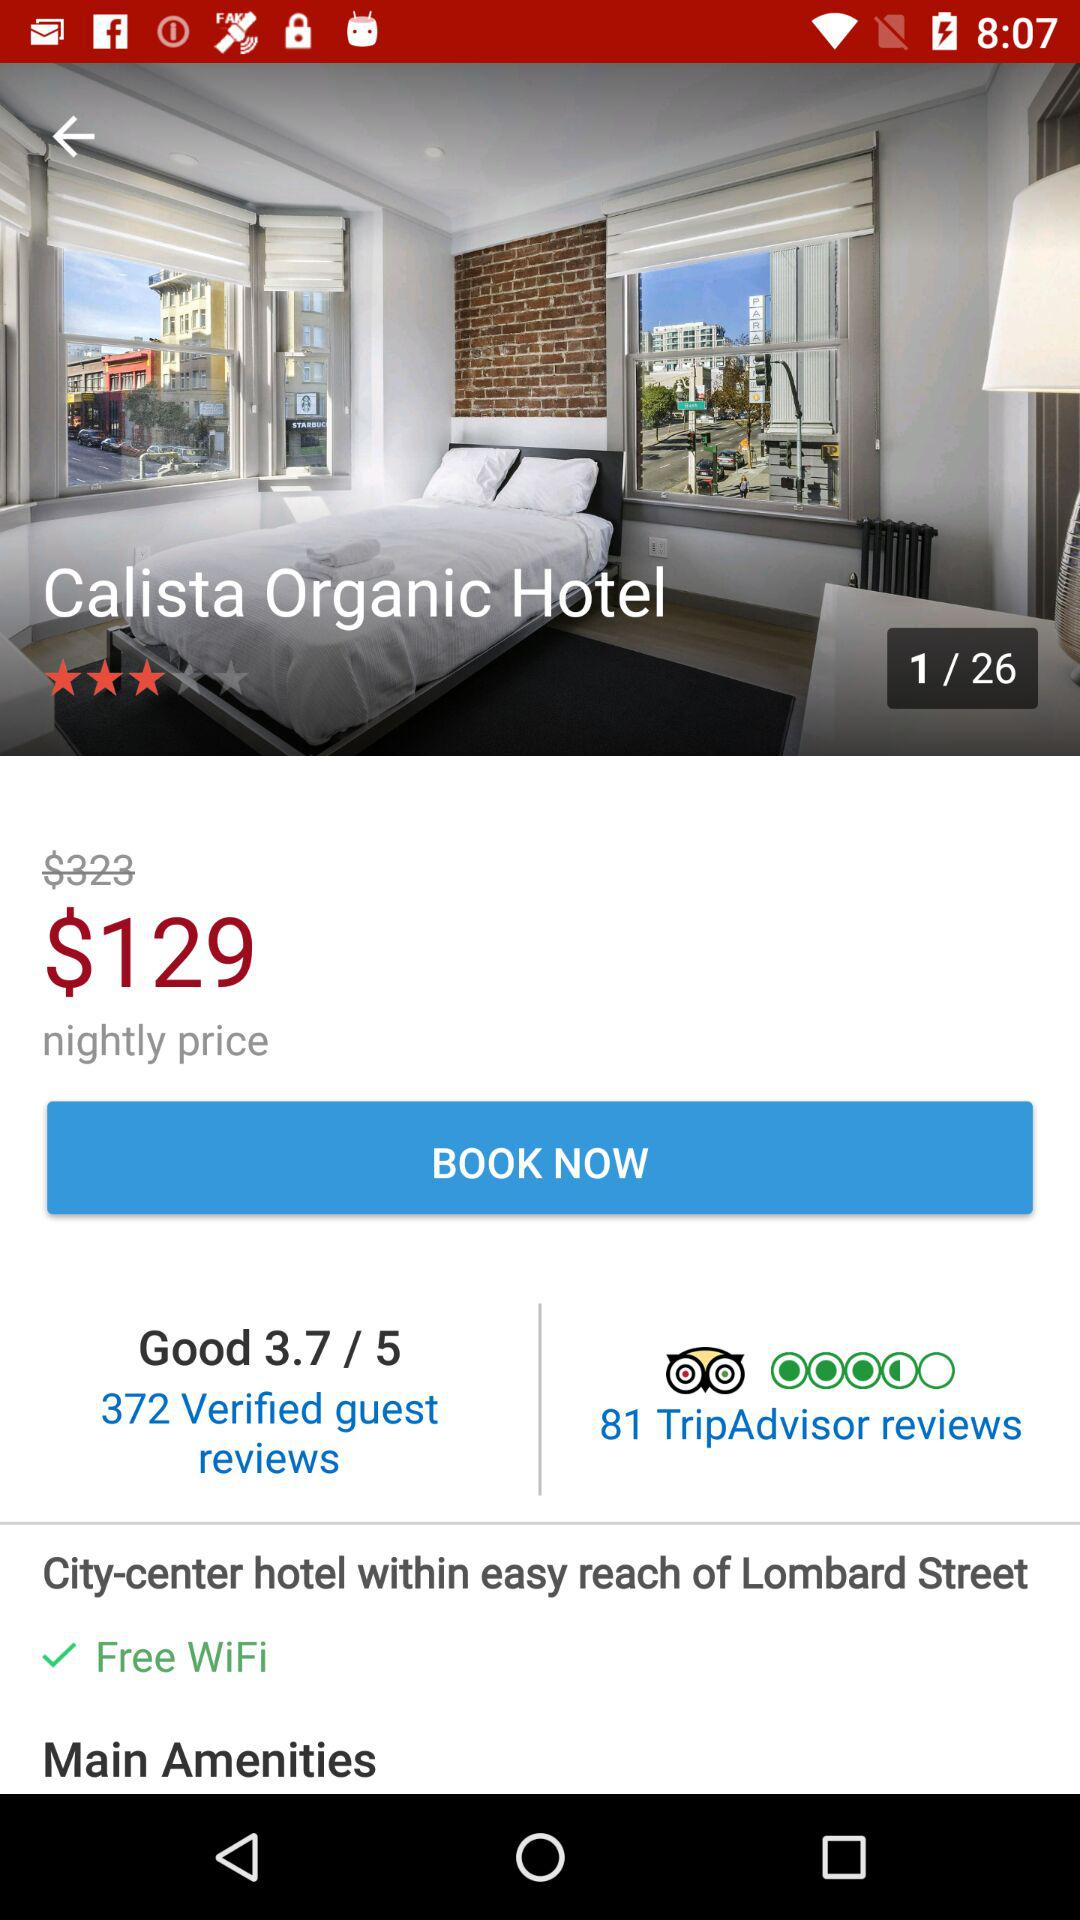How many TripAdvisor reviews does the hotel have?
Answer the question using a single word or phrase. 81 